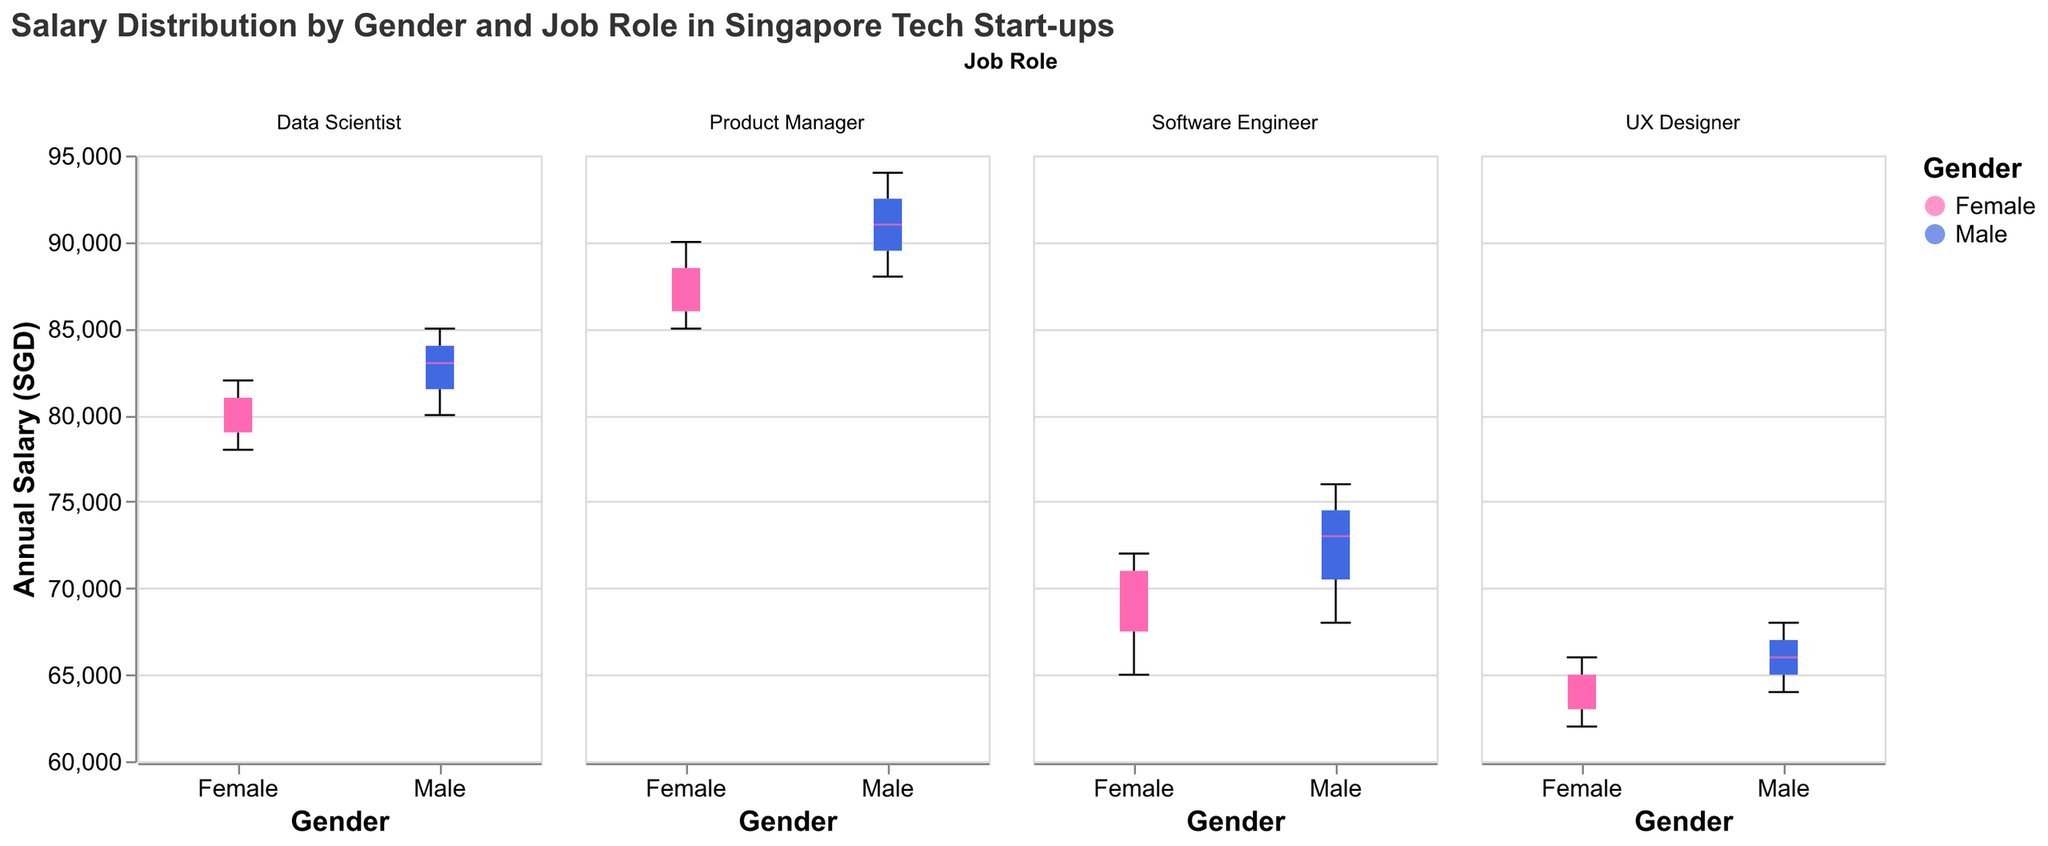What is the title of the figure? The title is displayed at the top of the figure and reads "Salary Distribution by Gender and Job Role in Singapore Tech Start-ups".
Answer: Salary Distribution by Gender and Job Role in Singapore Tech Start-ups How many job roles are represented in the figure? The figure facets the box plots by column, with each column representing a different job role. There are four columns, hence four job roles.
Answer: 4 What is the median salary for female Software Engineers? The median is indicated by a line within the box of the box plot for "Female" under the "Software Engineer" column.
Answer: 70000 Which gender has the higher salary range as Product Managers? Compare the range (difference between the minimum and maximum values) within the "Product Manager" box plots for both genders. Males show a wider range compared to females.
Answer: Male What is the minimum salary for male Data Scientists? The minimum value for male Data Scientists is marked by the lower whisker in the "Data Scientist" column's box plot for males.
Answer: 80000 What is the interquartile range (IQR) for female Data Scientists? The IQR is the range between the first quartile (bottom of the box) and the third quartile (top of the box) for female Data Scientists in the "Data Scientist" column.
Answer: 78000 to 82000 How does the median salary of female UX Designers compare to male UX Designers? Examine the median lines (within the boxes) in the "UX Designer" column for both genders. The median for females is lower than for males.
Answer: Lower What is the highest salary recorded for male Product Managers? The highest value is marked by the upper whisker in the "Product Manager" column's box plot for males.
Answer: 94000 Among Data Scientists, which gender has a higher median salary? Compare the median lines within the boxes for Data Scientists for both genders. Males have a higher median than females.
Answer: Male Which job role shows the smallest salary range for females? Compare the ranges (difference between minimum and maximum) for females across all job roles. UX Designer has the smallest range.
Answer: UX Designer 